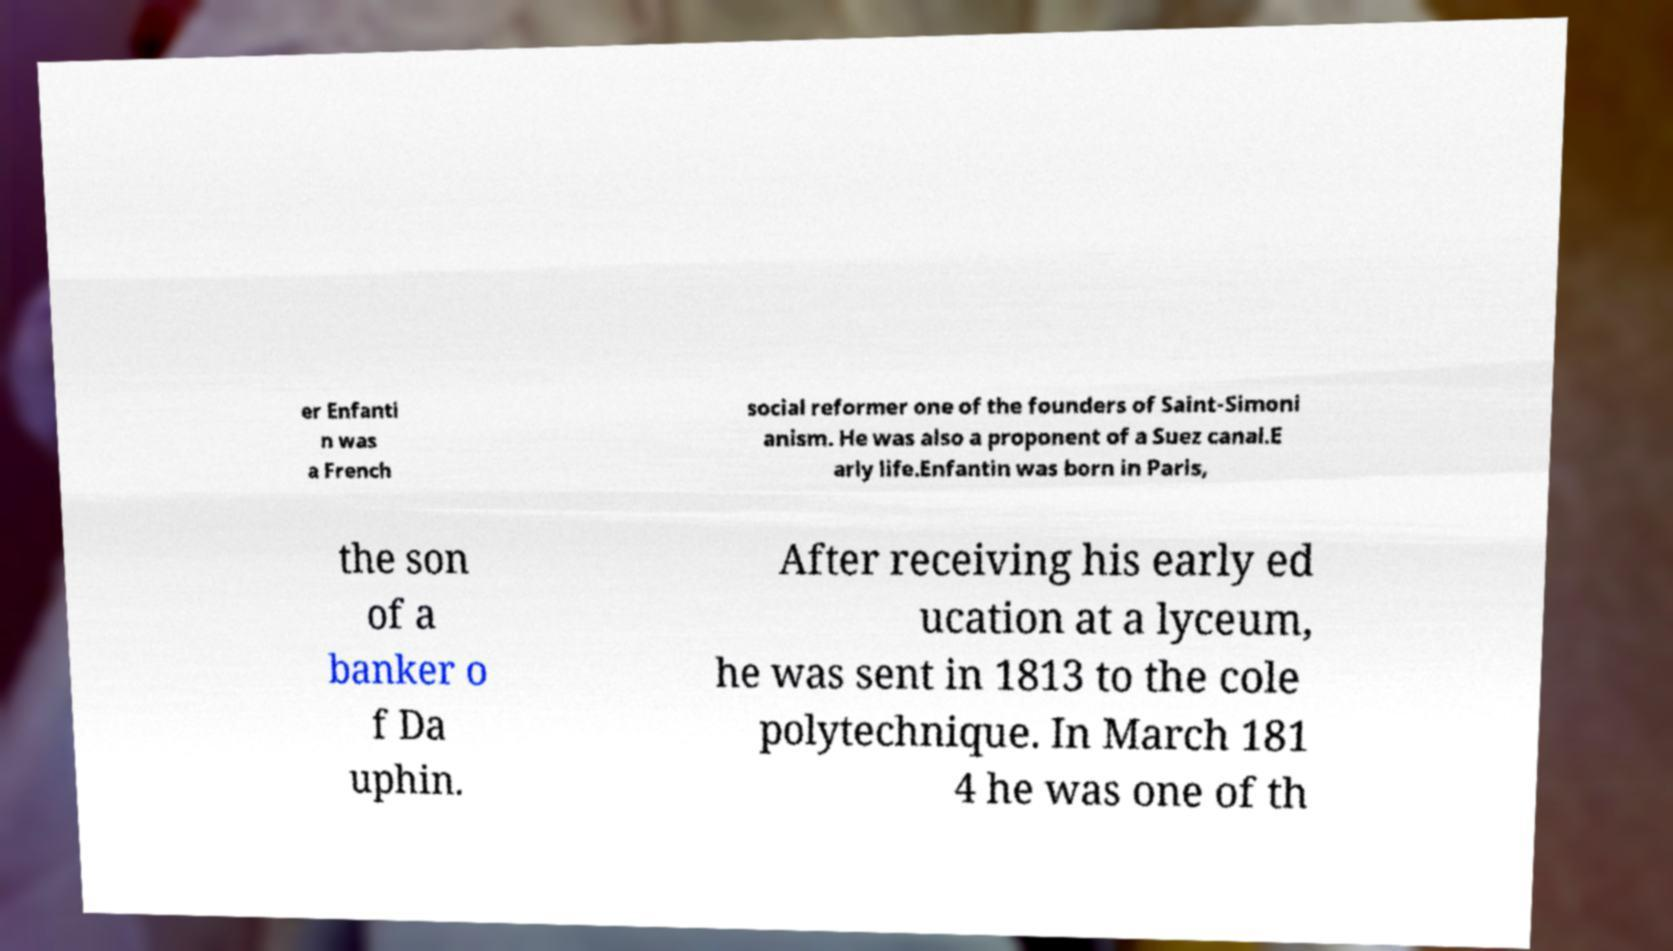Please read and relay the text visible in this image. What does it say? er Enfanti n was a French social reformer one of the founders of Saint-Simoni anism. He was also a proponent of a Suez canal.E arly life.Enfantin was born in Paris, the son of a banker o f Da uphin. After receiving his early ed ucation at a lyceum, he was sent in 1813 to the cole polytechnique. In March 181 4 he was one of th 